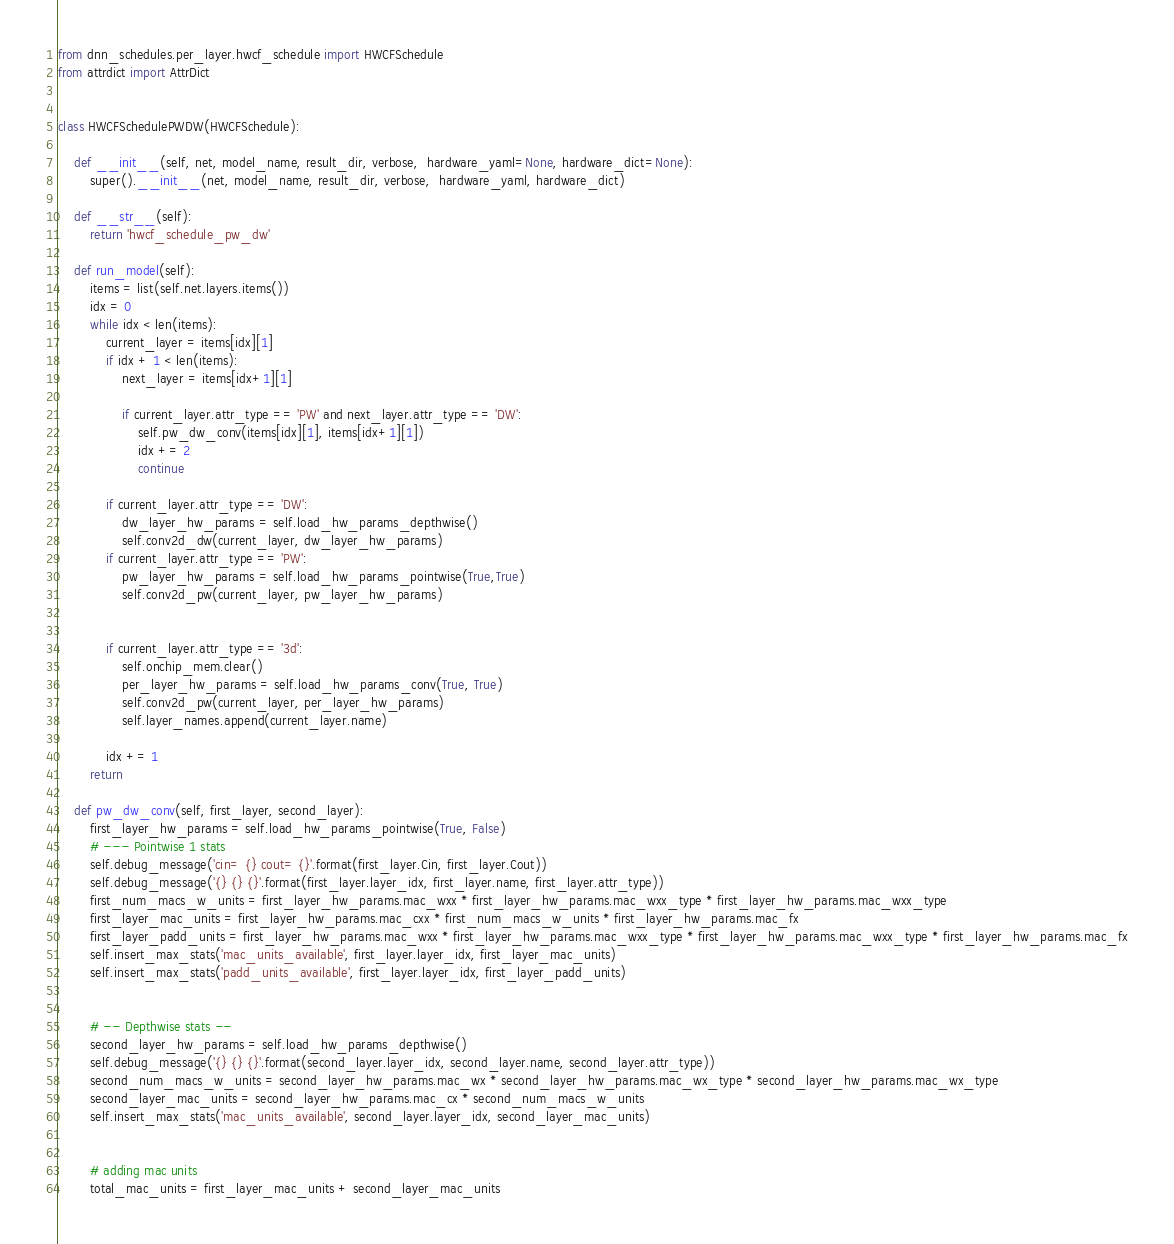Convert code to text. <code><loc_0><loc_0><loc_500><loc_500><_Python_>from dnn_schedules.per_layer.hwcf_schedule import HWCFSchedule
from attrdict import AttrDict


class HWCFSchedulePWDW(HWCFSchedule):

    def __init__(self, net, model_name, result_dir, verbose,  hardware_yaml=None, hardware_dict=None):
        super().__init__(net, model_name, result_dir, verbose,  hardware_yaml, hardware_dict)

    def __str__(self):
        return 'hwcf_schedule_pw_dw'

    def run_model(self):
        items = list(self.net.layers.items())
        idx = 0
        while idx < len(items):
            current_layer = items[idx][1]
            if idx + 1 < len(items):
                next_layer = items[idx+1][1]

                if current_layer.attr_type == 'PW' and next_layer.attr_type == 'DW':
                    self.pw_dw_conv(items[idx][1], items[idx+1][1])
                    idx += 2
                    continue

            if current_layer.attr_type == 'DW':
                dw_layer_hw_params = self.load_hw_params_depthwise()
                self.conv2d_dw(current_layer, dw_layer_hw_params)
            if current_layer.attr_type == 'PW':
                pw_layer_hw_params = self.load_hw_params_pointwise(True,True)
                self.conv2d_pw(current_layer, pw_layer_hw_params)


            if current_layer.attr_type == '3d':
                self.onchip_mem.clear()
                per_layer_hw_params = self.load_hw_params_conv(True, True)
                self.conv2d_pw(current_layer, per_layer_hw_params)
                self.layer_names.append(current_layer.name)

            idx += 1
        return

    def pw_dw_conv(self, first_layer, second_layer):
        first_layer_hw_params = self.load_hw_params_pointwise(True, False)
        # --- Pointwise 1 stats
        self.debug_message('cin= {} cout= {}'.format(first_layer.Cin, first_layer.Cout))
        self.debug_message('{} {} {}'.format(first_layer.layer_idx, first_layer.name, first_layer.attr_type))
        first_num_macs_w_units = first_layer_hw_params.mac_wxx * first_layer_hw_params.mac_wxx_type * first_layer_hw_params.mac_wxx_type
        first_layer_mac_units = first_layer_hw_params.mac_cxx * first_num_macs_w_units * first_layer_hw_params.mac_fx
        first_layer_padd_units = first_layer_hw_params.mac_wxx * first_layer_hw_params.mac_wxx_type * first_layer_hw_params.mac_wxx_type * first_layer_hw_params.mac_fx
        self.insert_max_stats('mac_units_available', first_layer.layer_idx, first_layer_mac_units)
        self.insert_max_stats('padd_units_available', first_layer.layer_idx, first_layer_padd_units)


        # -- Depthwise stats --
        second_layer_hw_params = self.load_hw_params_depthwise()
        self.debug_message('{} {} {}'.format(second_layer.layer_idx, second_layer.name, second_layer.attr_type))
        second_num_macs_w_units = second_layer_hw_params.mac_wx * second_layer_hw_params.mac_wx_type * second_layer_hw_params.mac_wx_type
        second_layer_mac_units = second_layer_hw_params.mac_cx * second_num_macs_w_units
        self.insert_max_stats('mac_units_available', second_layer.layer_idx, second_layer_mac_units)


        # adding mac units
        total_mac_units = first_layer_mac_units + second_layer_mac_units</code> 